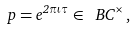Convert formula to latex. <formula><loc_0><loc_0><loc_500><loc_500>p = e ^ { 2 \pi \iota \tau } \in \ B C ^ { \times } \, ,</formula> 